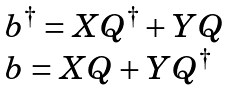Convert formula to latex. <formula><loc_0><loc_0><loc_500><loc_500>\begin{array} { l } b ^ { \dagger } = X Q ^ { \dagger } + Y Q \\ b = X Q + Y Q ^ { \dagger } \end{array}</formula> 